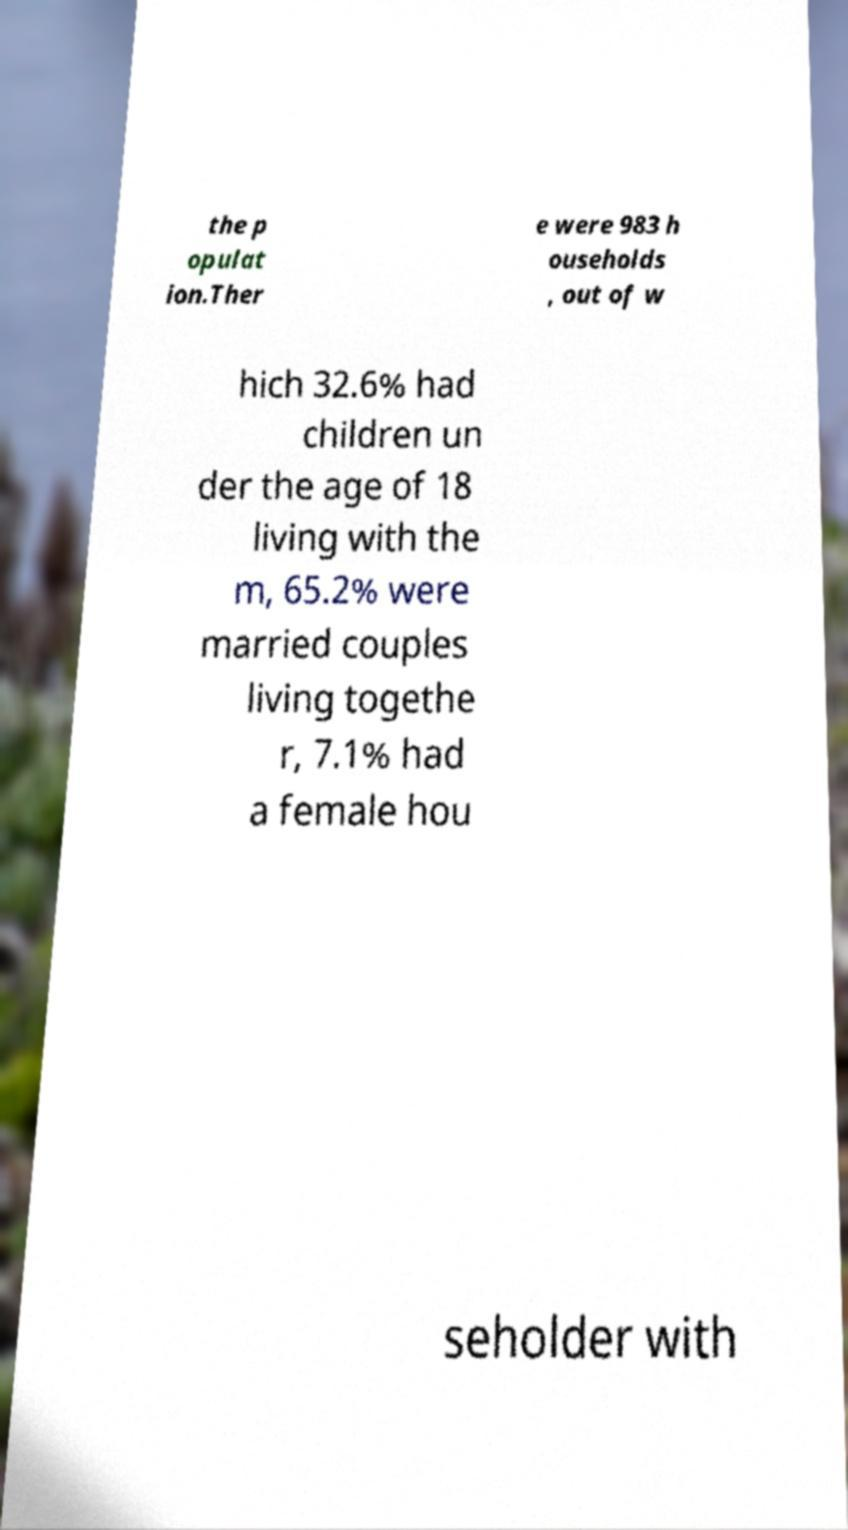There's text embedded in this image that I need extracted. Can you transcribe it verbatim? the p opulat ion.Ther e were 983 h ouseholds , out of w hich 32.6% had children un der the age of 18 living with the m, 65.2% were married couples living togethe r, 7.1% had a female hou seholder with 